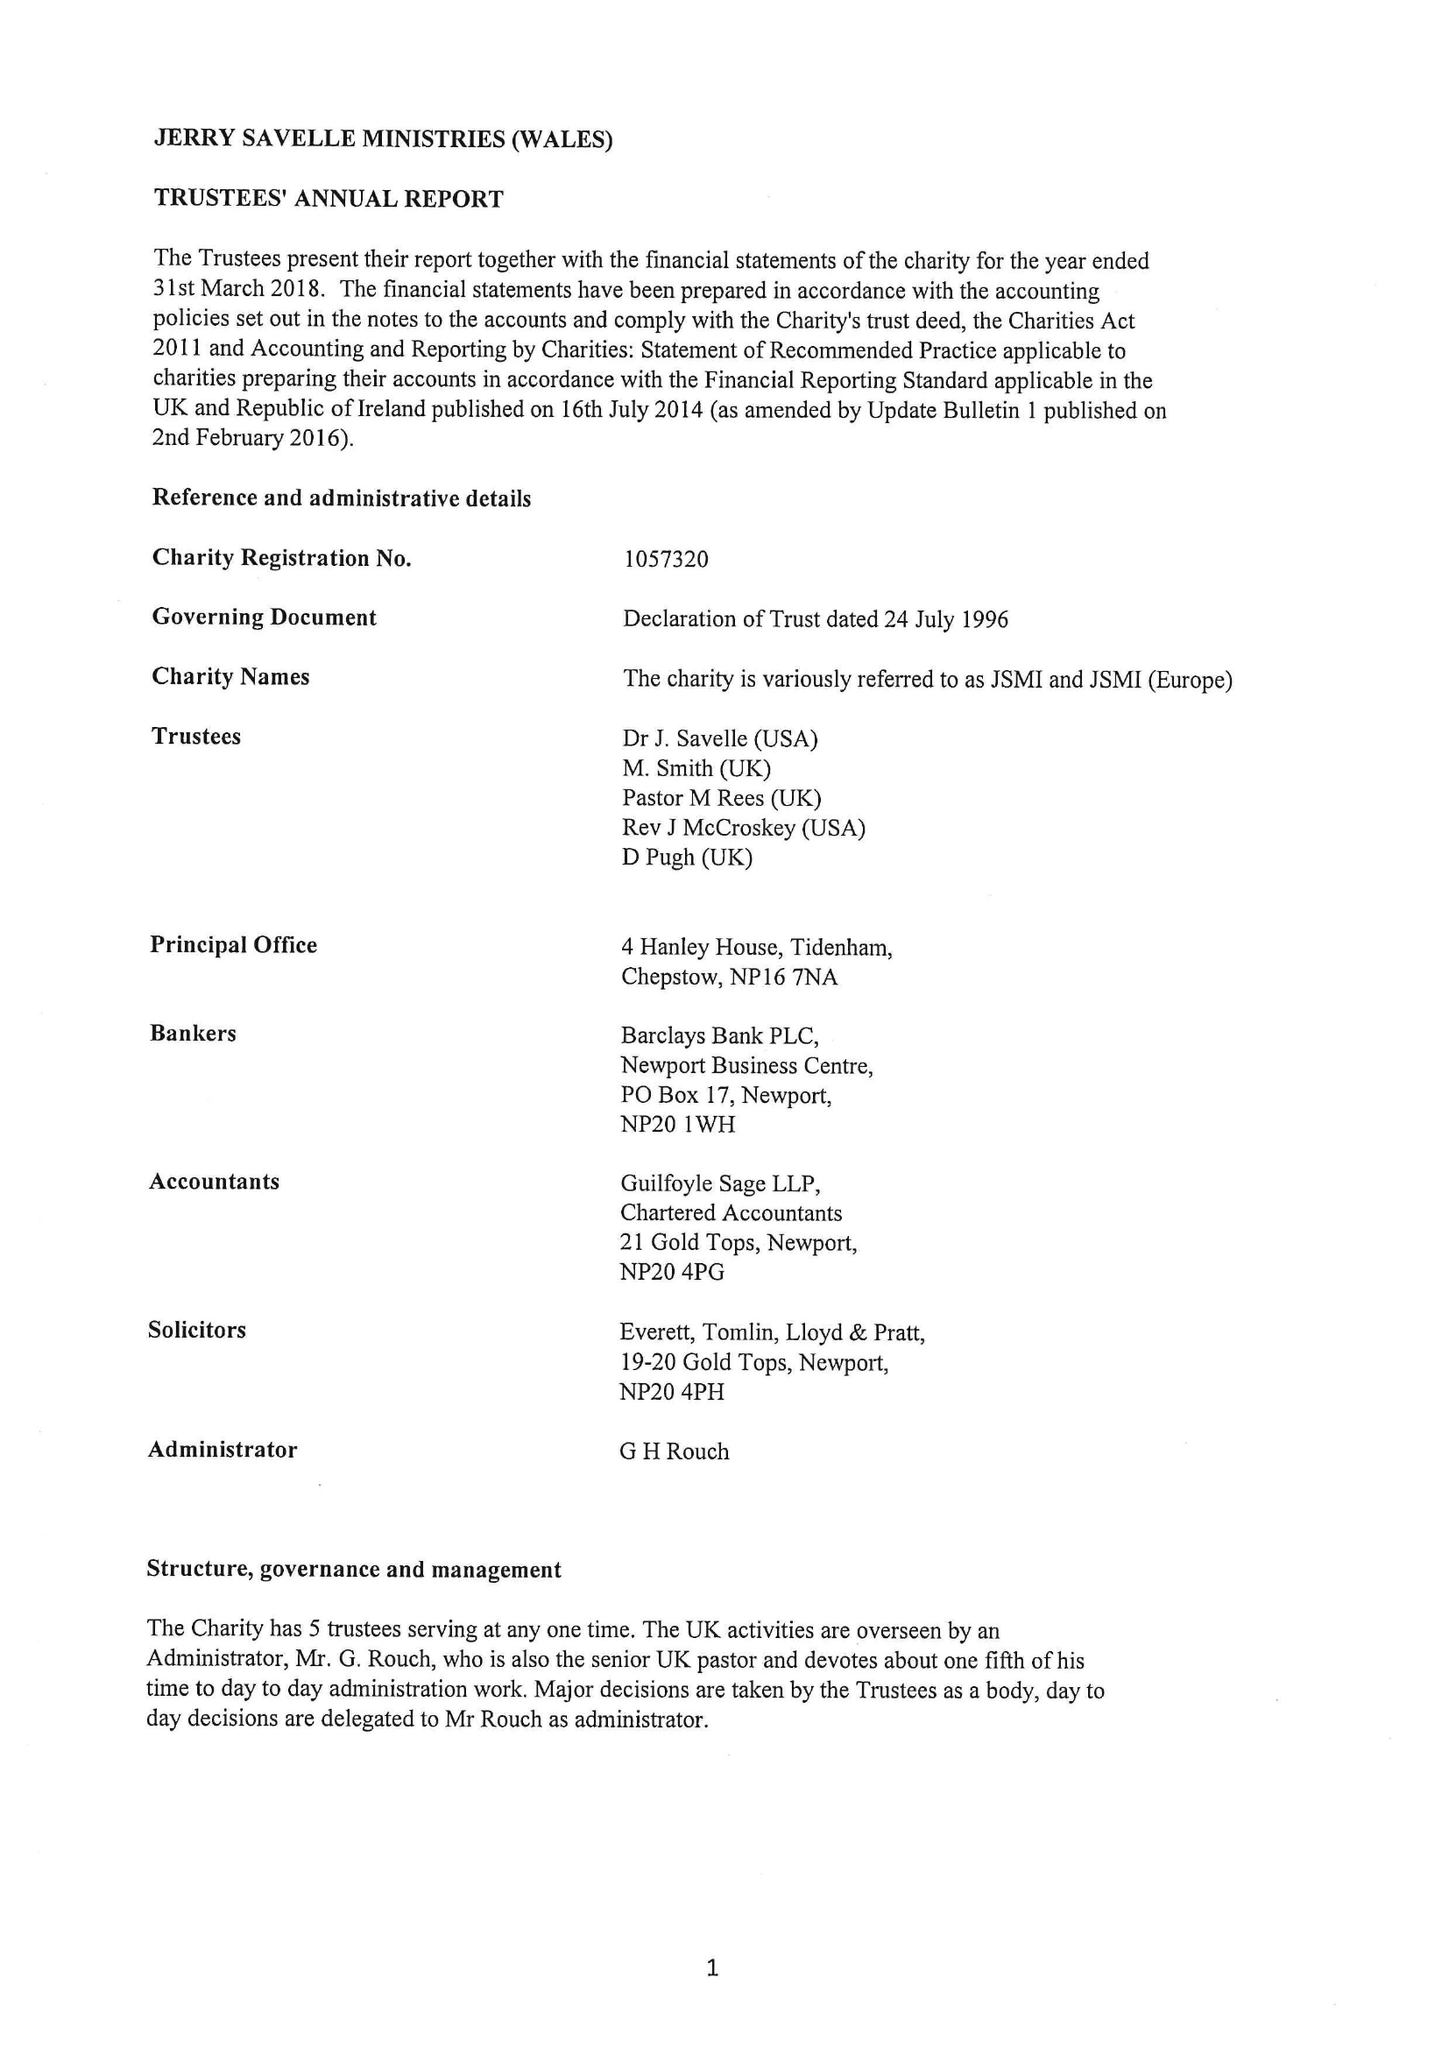What is the value for the spending_annually_in_british_pounds?
Answer the question using a single word or phrase. 231208.00 